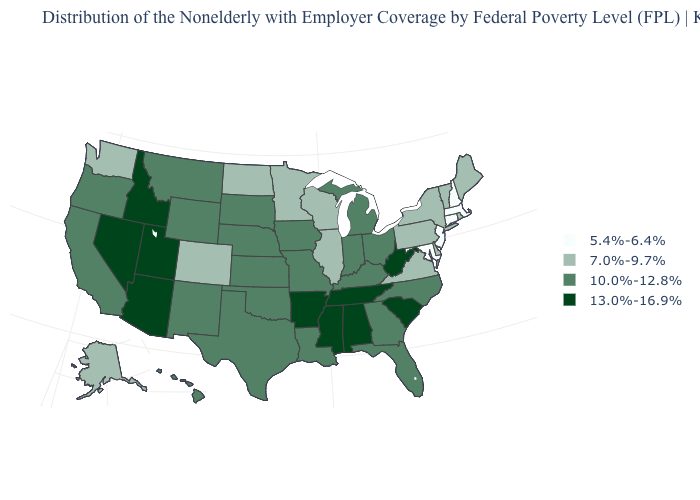Does the first symbol in the legend represent the smallest category?
Write a very short answer. Yes. What is the value of Virginia?
Keep it brief. 7.0%-9.7%. Name the states that have a value in the range 7.0%-9.7%?
Answer briefly. Alaska, Colorado, Delaware, Illinois, Maine, Minnesota, New York, North Dakota, Pennsylvania, Rhode Island, Vermont, Virginia, Washington, Wisconsin. Does North Dakota have a higher value than Idaho?
Concise answer only. No. Does Maine have the lowest value in the Northeast?
Concise answer only. No. Which states hav the highest value in the Northeast?
Give a very brief answer. Maine, New York, Pennsylvania, Rhode Island, Vermont. Which states have the highest value in the USA?
Be succinct. Alabama, Arizona, Arkansas, Idaho, Mississippi, Nevada, South Carolina, Tennessee, Utah, West Virginia. Which states have the lowest value in the USA?
Give a very brief answer. Connecticut, Maryland, Massachusetts, New Hampshire, New Jersey. Among the states that border Wisconsin , which have the lowest value?
Write a very short answer. Illinois, Minnesota. Name the states that have a value in the range 10.0%-12.8%?
Keep it brief. California, Florida, Georgia, Hawaii, Indiana, Iowa, Kansas, Kentucky, Louisiana, Michigan, Missouri, Montana, Nebraska, New Mexico, North Carolina, Ohio, Oklahoma, Oregon, South Dakota, Texas, Wyoming. What is the value of North Dakota?
Concise answer only. 7.0%-9.7%. Among the states that border Maine , which have the highest value?
Quick response, please. New Hampshire. Which states hav the highest value in the MidWest?
Give a very brief answer. Indiana, Iowa, Kansas, Michigan, Missouri, Nebraska, Ohio, South Dakota. What is the value of Kansas?
Answer briefly. 10.0%-12.8%. Name the states that have a value in the range 7.0%-9.7%?
Write a very short answer. Alaska, Colorado, Delaware, Illinois, Maine, Minnesota, New York, North Dakota, Pennsylvania, Rhode Island, Vermont, Virginia, Washington, Wisconsin. 